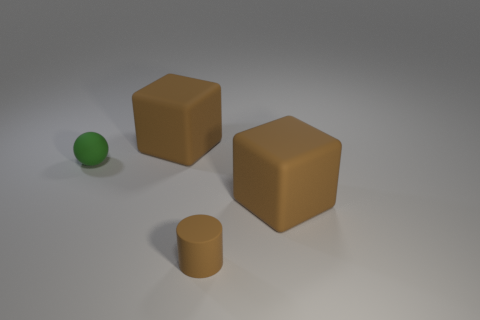Are there any matte balls of the same size as the green rubber thing? Based on the image, there are no objects that qualify as matte balls of the same size as the green sphere. The green object appears to be a small, shiny rubber ball and the only other spherical object is much smaller and has a different texture. 